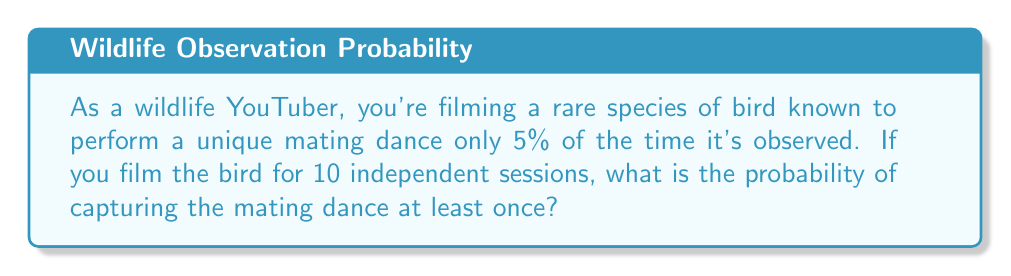Can you answer this question? Let's approach this step-by-step:

1) First, we need to identify that this is a binomial probability problem.

2) Let's define our events:
   - Success: Capturing the mating dance
   - Failure: Not capturing the mating dance

3) We know that:
   - Probability of success in one session, $p = 0.05$ (5%)
   - Number of trials, $n = 10$
   - We want at least one success

4) It's often easier to calculate the probability of the complement event (no successes) and then subtract from 1:

   $P(\text{at least one success}) = 1 - P(\text{no successes})$

5) The probability of no successes in 10 trials is:

   $P(\text{no successes}) = (1-p)^n = (0.95)^{10}$

6) Therefore, the probability of at least one success is:

   $P(\text{at least one success}) = 1 - (0.95)^{10}$

7) Calculating this:
   
   $1 - (0.95)^{10} = 1 - 0.5987 = 0.4013$

8) Converting to a percentage:

   $0.4013 \times 100\% = 40.13\%$
Answer: 40.13% 